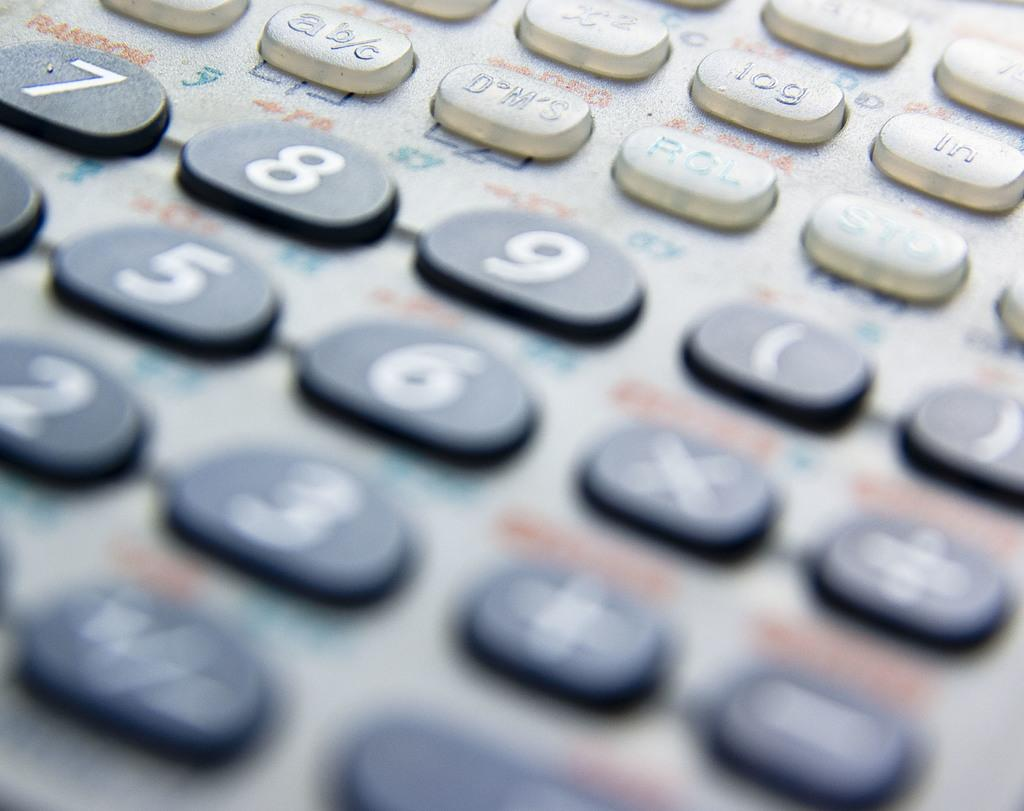What type of device is visible in the image? There is a device in the image that might be a calculator. What can be found on the device? The device has numbers, special characters, and letters on it. What type of underwear is visible in the image? There is no underwear present in the image. What things are being dropped in the image? There is no indication of anything being dropped in the image. 